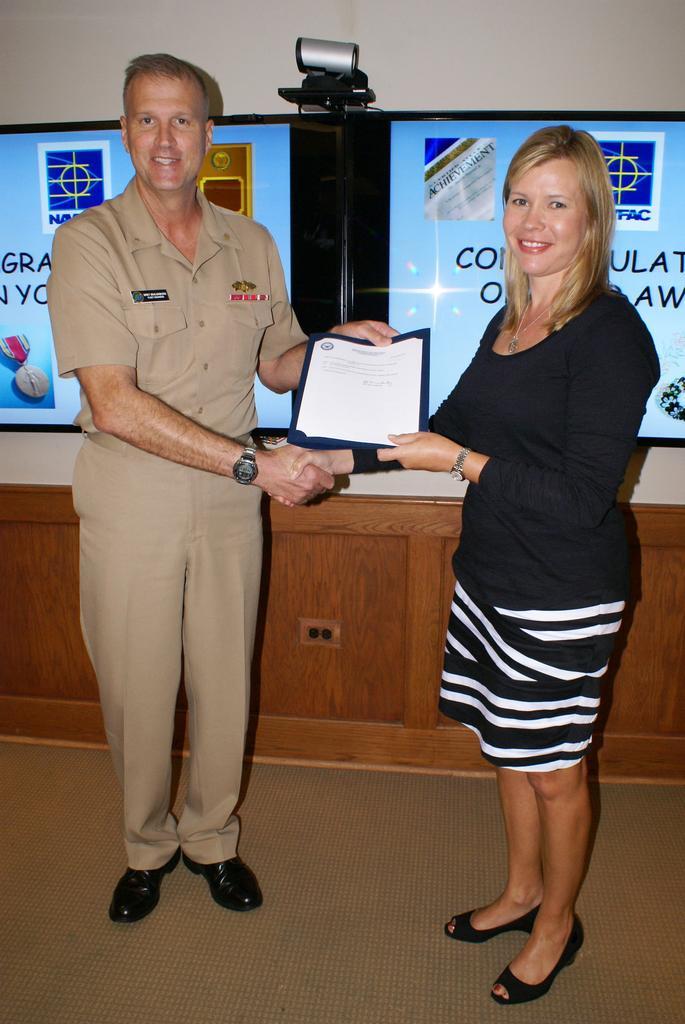How would you summarize this image in a sentence or two? In this picture we can see a man and a woman is holding a certificate. Behind the people, there are boards, an object and the wall. 